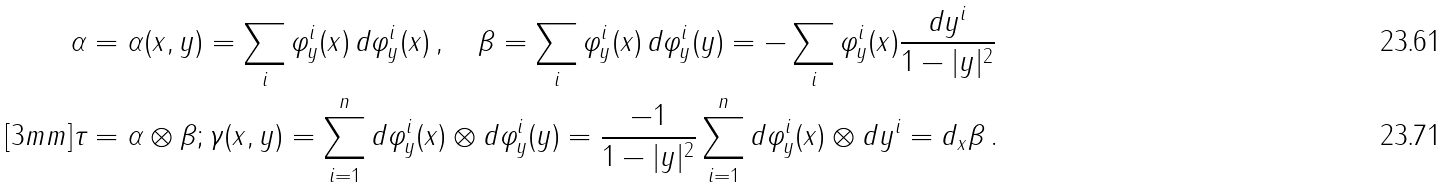<formula> <loc_0><loc_0><loc_500><loc_500>\alpha & = \alpha ( x , y ) = \sum _ { i } \varphi _ { y } ^ { i } ( x ) \, d \varphi _ { y } ^ { i } ( x ) \, , \quad \beta = \sum _ { i } \varphi _ { y } ^ { i } ( x ) \, d \varphi _ { y } ^ { i } ( y ) = - \sum _ { i } \varphi _ { y } ^ { i } ( x ) \frac { d y ^ { i } } { 1 - | y | ^ { 2 } } \\ [ 3 m m ] \tau & = \alpha \otimes \beta ; \gamma ( x , y ) = \sum _ { i = 1 } ^ { n } d \varphi _ { y } ^ { i } ( x ) \otimes d \varphi _ { y } ^ { i } ( y ) = \frac { - 1 } { 1 - | y | ^ { 2 } } \sum _ { i = 1 } ^ { n } d \varphi _ { y } ^ { i } ( x ) \otimes d y ^ { i } = d _ { x } \beta \, .</formula> 